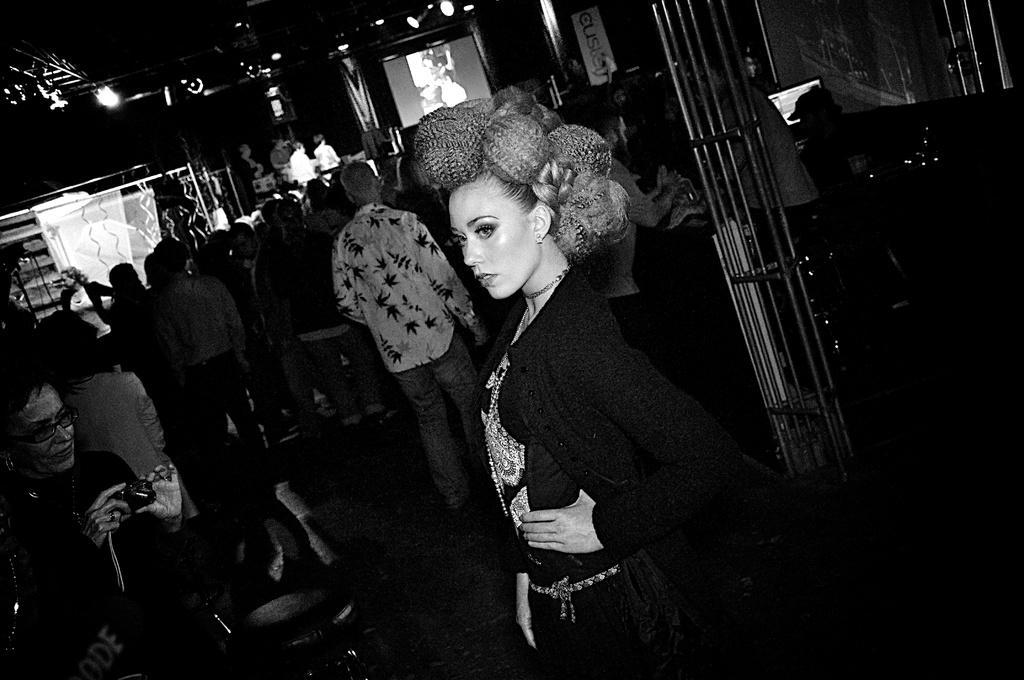Describe this image in one or two sentences. It is a black and white picture. In this picture I can see people, rods, screens, focusing lights, banner and objects. In the front of the image a woman is holding a camera. 